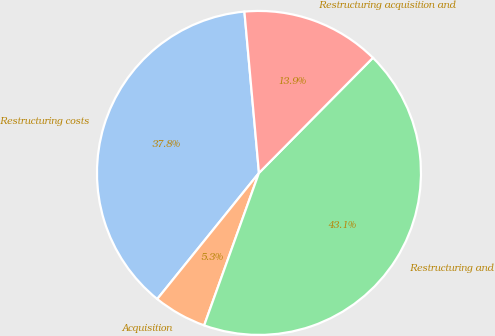<chart> <loc_0><loc_0><loc_500><loc_500><pie_chart><fcel>Restructuring costs<fcel>Acquisition<fcel>Restructuring and<fcel>Restructuring acquisition and<nl><fcel>37.76%<fcel>5.31%<fcel>43.07%<fcel>13.85%<nl></chart> 